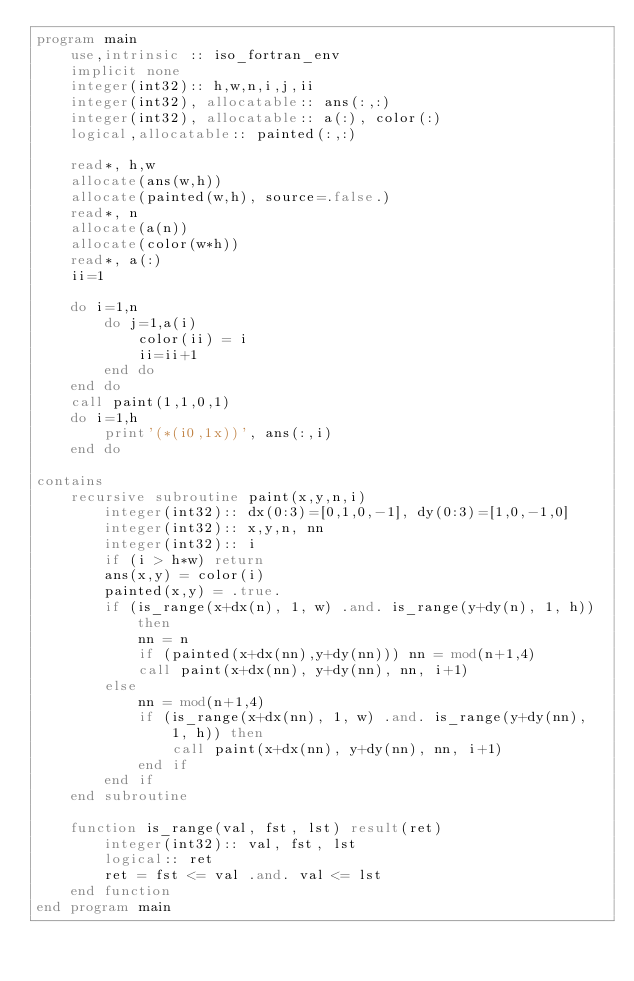Convert code to text. <code><loc_0><loc_0><loc_500><loc_500><_FORTRAN_>program main
    use,intrinsic :: iso_fortran_env
    implicit none
    integer(int32):: h,w,n,i,j,ii
    integer(int32), allocatable:: ans(:,:)
    integer(int32), allocatable:: a(:), color(:)
    logical,allocatable:: painted(:,:)

    read*, h,w
    allocate(ans(w,h))
    allocate(painted(w,h), source=.false.)
    read*, n
    allocate(a(n))
    allocate(color(w*h))
    read*, a(:)
    ii=1

    do i=1,n
        do j=1,a(i)
            color(ii) = i
            ii=ii+1
        end do
    end do
    call paint(1,1,0,1)
    do i=1,h
        print'(*(i0,1x))', ans(:,i)
    end do

contains
    recursive subroutine paint(x,y,n,i)
        integer(int32):: dx(0:3)=[0,1,0,-1], dy(0:3)=[1,0,-1,0]
        integer(int32):: x,y,n, nn
        integer(int32):: i
        if (i > h*w) return
        ans(x,y) = color(i)
        painted(x,y) = .true.
        if (is_range(x+dx(n), 1, w) .and. is_range(y+dy(n), 1, h)) then
            nn = n
            if (painted(x+dx(nn),y+dy(nn))) nn = mod(n+1,4)
            call paint(x+dx(nn), y+dy(nn), nn, i+1)
        else
            nn = mod(n+1,4)
            if (is_range(x+dx(nn), 1, w) .and. is_range(y+dy(nn), 1, h)) then
                call paint(x+dx(nn), y+dy(nn), nn, i+1)
            end if
        end if
    end subroutine

    function is_range(val, fst, lst) result(ret)
        integer(int32):: val, fst, lst
        logical:: ret
        ret = fst <= val .and. val <= lst
    end function
end program main</code> 